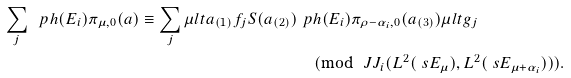Convert formula to latex. <formula><loc_0><loc_0><loc_500><loc_500>\sum _ { j } \ p h ( E _ { i } ) \pi _ { \mu , 0 } ( a ) \equiv \sum _ { j } \mu l t { a _ { ( 1 ) } f _ { j } S ( a _ { ( 2 ) } ) } & \ p h ( E _ { i } ) \pi _ { \rho - \alpha _ { i } , 0 } ( a _ { ( 3 ) } ) \mu l t { g _ { j } } \\ & \pmod { \ J J _ { i } ( L ^ { 2 } ( \ s E _ { \mu } ) , L ^ { 2 } ( \ s E _ { \mu + \alpha _ { i } } ) ) } .</formula> 